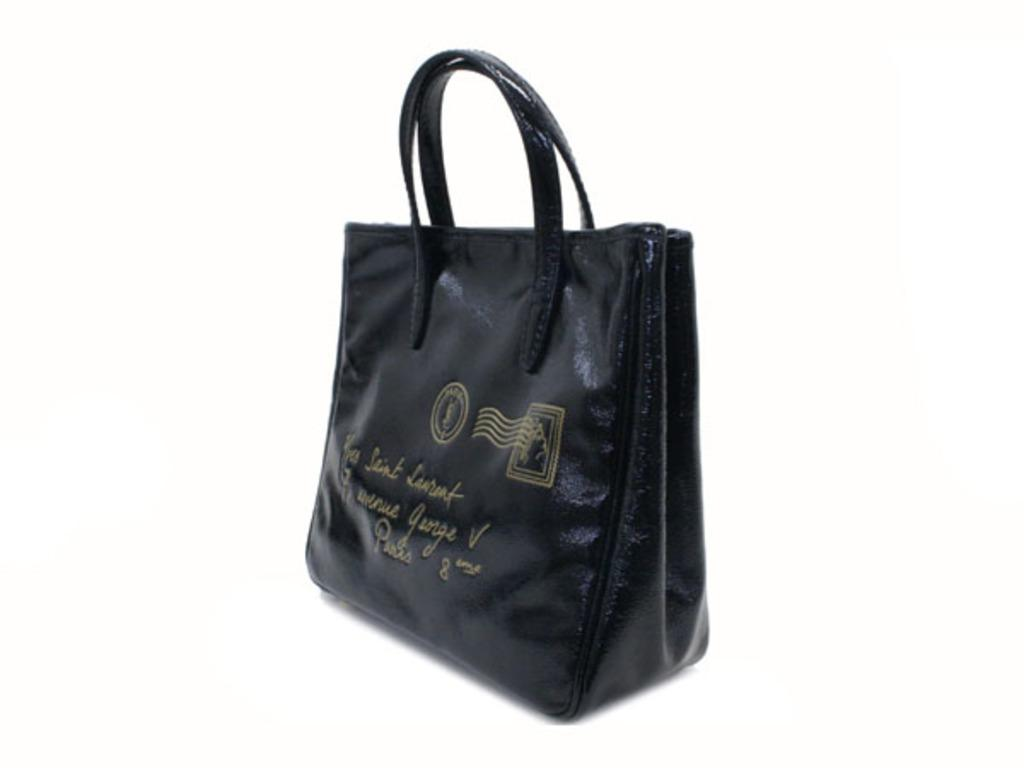What material is the handbag made of? The handbag is made of leather. How many children are playing with the handbag in the image? There are no children present in the image, and the handbag is not being played with. 